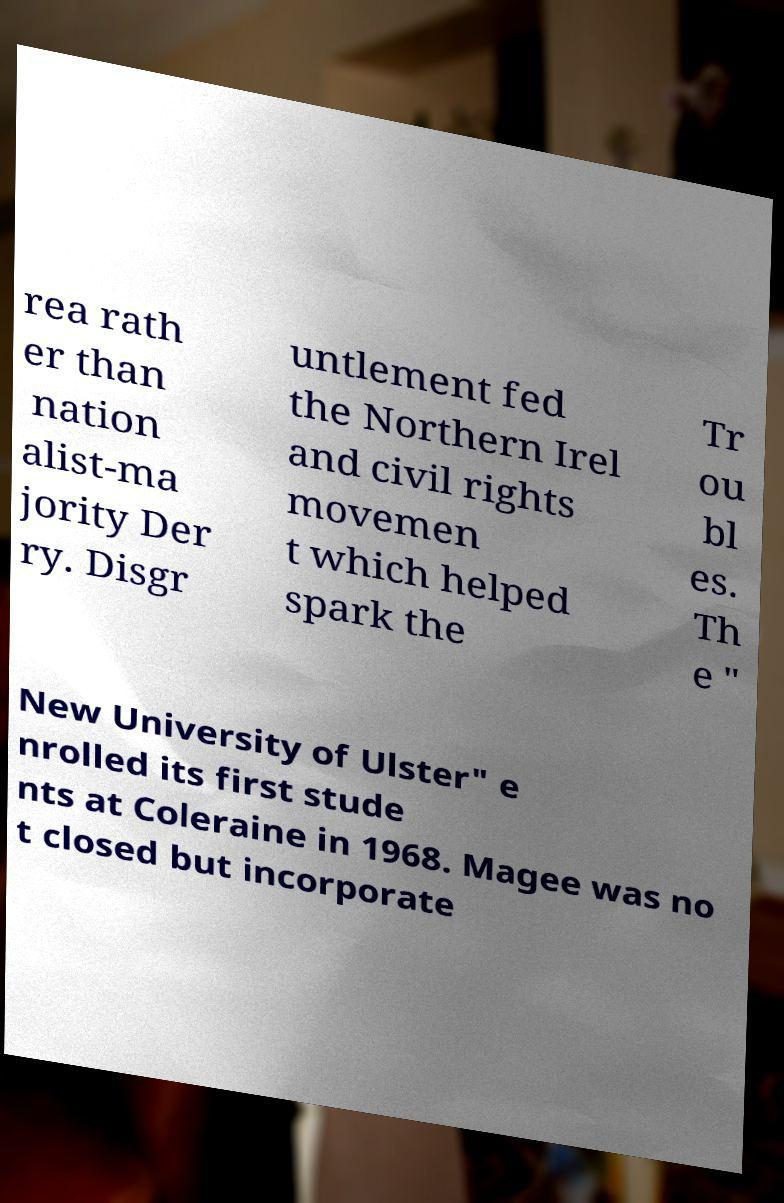Please read and relay the text visible in this image. What does it say? rea rath er than nation alist-ma jority Der ry. Disgr untlement fed the Northern Irel and civil rights movemen t which helped spark the Tr ou bl es. Th e " New University of Ulster" e nrolled its first stude nts at Coleraine in 1968. Magee was no t closed but incorporate 